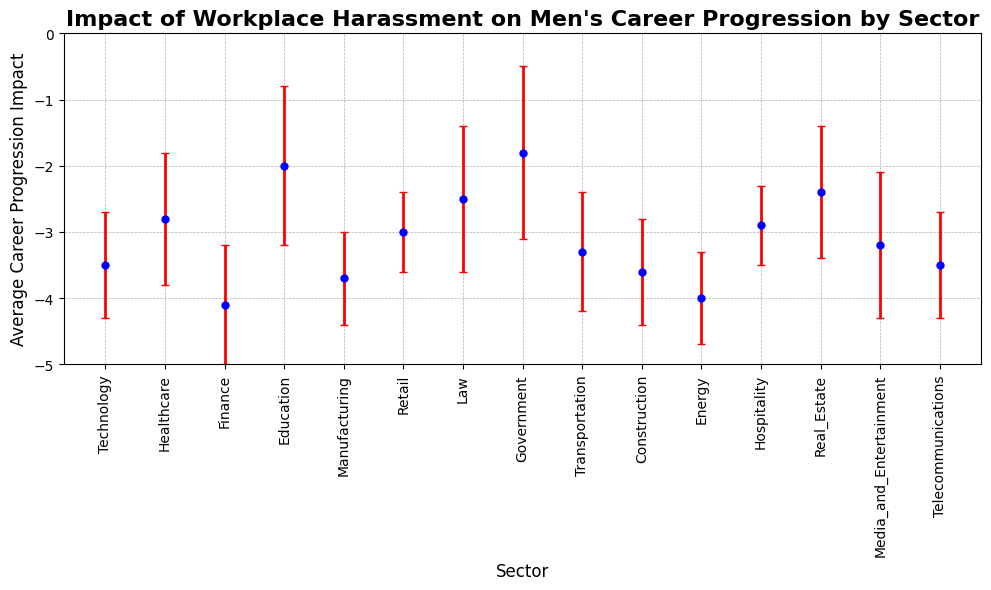Which sector has the highest average career progression impact from workplace harassment? By observing the y-axis, we note that the higher (less negative) the impact value, the less severe the impact. The Government sector has the highest (least negative) value at -1.8.
Answer: Government Which two sectors have the same average career progression impact of -3.5? By matching the y-values to the sectors, we see that both the Technology and Telecommunications sectors have an average impact of -3.5.
Answer: Technology and Telecommunications Which sector shows the greatest variance in the impact of workplace harassment on men's career progression? The sector with the highest standard deviation indicates the greatest variance. Here, Government has a standard deviation of 1.3, the largest among all sectors.
Answer: Government What is the difference in the average career progression impact between the Finance and Government sectors? The average impact for Finance is -4.1 and for Government is -1.8. Subtracting these gives -4.1 - (-1.8) = -2.3.
Answer: -2.3 How does the average career progression impact in the Technology sector compare to the Healthcare sector? The Technology sector has an average impact of -3.5, whereas Healthcare has -2.8. The impact in Technology is more negative, indicating a greater detrimental effect.
Answer: More negative in Technology What range does the average career progression impact of the sectors fall within? Observing the y-axis, the highest average impact is -1.8 (Government) and the lowest is -4.1 (Finance), so the range is from -4.1 to -1.8.
Answer: -4.1 to -1.8 Which sector has the smallest standard deviation, indicating the least variability in impact? The sector with the smallest standard deviation is Retail with a value of 0.6.
Answer: Retail If you average the impacts of Technology and Finance sectors together, what is the resulting average impact? The average impact of Technology is -3.5 and Finance is -4.1. Averaging these together: (-3.5 + -4.1) / 2 = -3.8.
Answer: -3.8 Looking at the error bars, which sector shows the widest range of potential impact values? The Government sector has the largest error bar, with a standard deviation of 1.3, indicating the widest range of potential impact values.
Answer: Government 